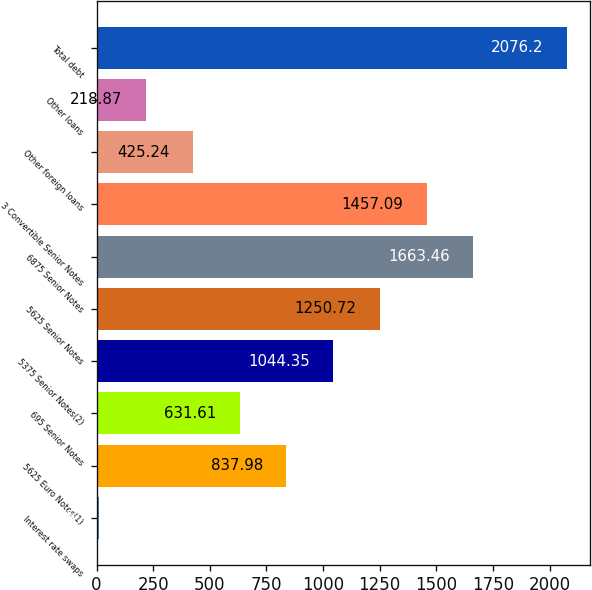Convert chart. <chart><loc_0><loc_0><loc_500><loc_500><bar_chart><fcel>Interest rate swaps<fcel>5625 Euro Notes(1)<fcel>695 Senior Notes<fcel>5375 Senior Notes(2)<fcel>5625 Senior Notes<fcel>6875 Senior Notes<fcel>3 Convertible Senior Notes<fcel>Other foreign loans<fcel>Other loans<fcel>Total debt<nl><fcel>12.5<fcel>837.98<fcel>631.61<fcel>1044.35<fcel>1250.72<fcel>1663.46<fcel>1457.09<fcel>425.24<fcel>218.87<fcel>2076.2<nl></chart> 